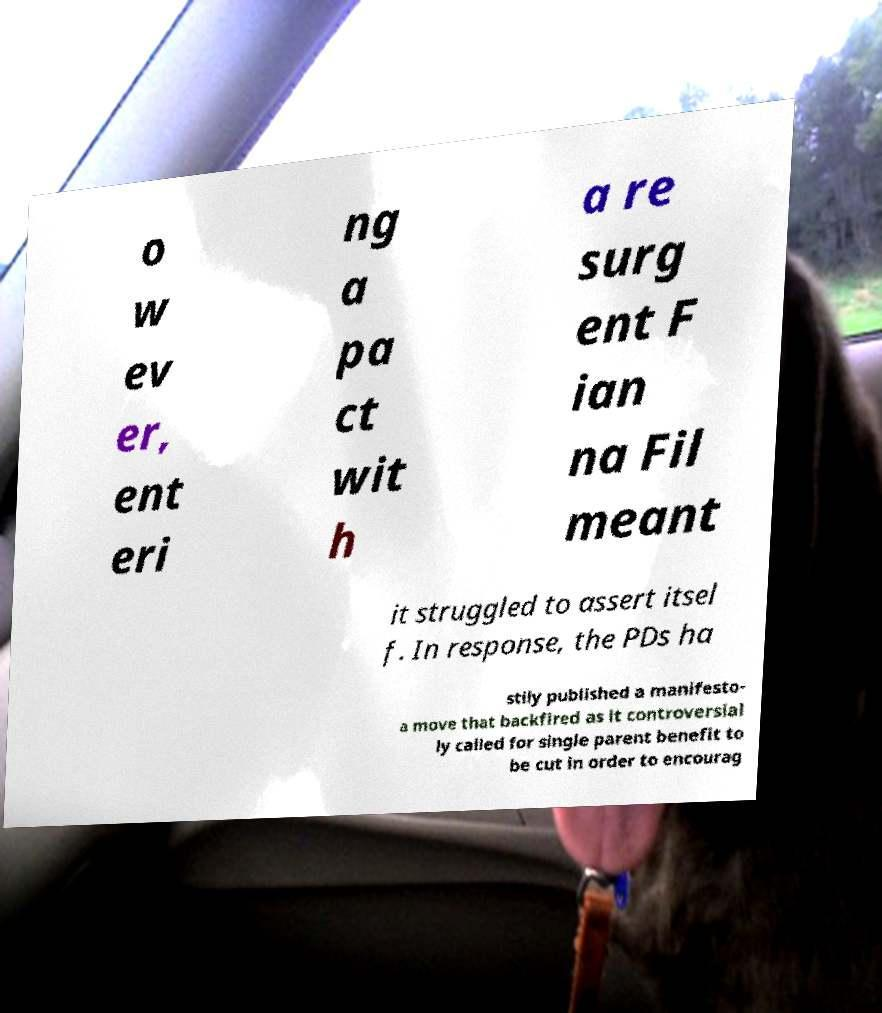What messages or text are displayed in this image? I need them in a readable, typed format. o w ev er, ent eri ng a pa ct wit h a re surg ent F ian na Fil meant it struggled to assert itsel f. In response, the PDs ha stily published a manifesto- a move that backfired as it controversial ly called for single parent benefit to be cut in order to encourag 